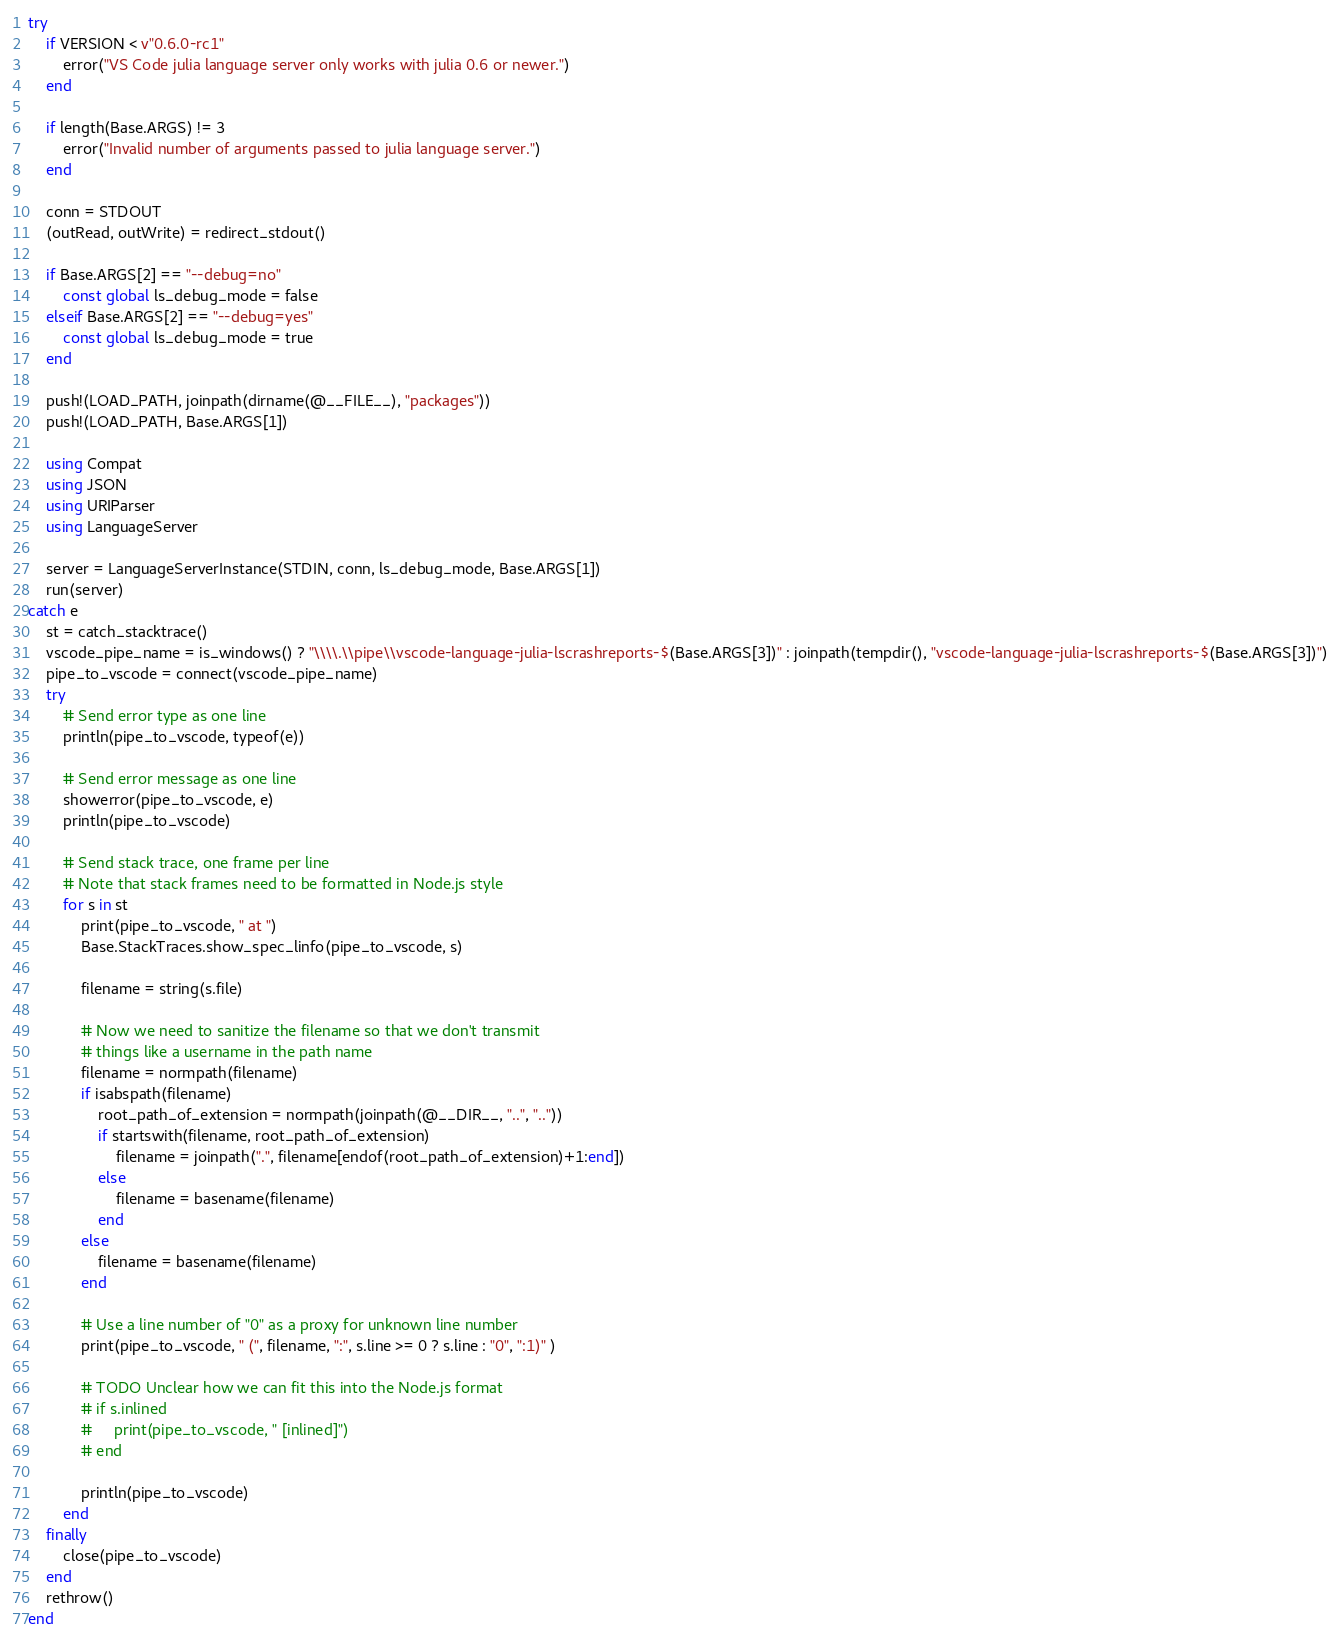Convert code to text. <code><loc_0><loc_0><loc_500><loc_500><_Julia_>try
    if VERSION < v"0.6.0-rc1"
        error("VS Code julia language server only works with julia 0.6 or newer.")
    end

    if length(Base.ARGS) != 3
        error("Invalid number of arguments passed to julia language server.")
    end

    conn = STDOUT
    (outRead, outWrite) = redirect_stdout()

    if Base.ARGS[2] == "--debug=no"
        const global ls_debug_mode = false
    elseif Base.ARGS[2] == "--debug=yes"
        const global ls_debug_mode = true
    end

    push!(LOAD_PATH, joinpath(dirname(@__FILE__), "packages"))
    push!(LOAD_PATH, Base.ARGS[1])

    using Compat
    using JSON
    using URIParser
    using LanguageServer

    server = LanguageServerInstance(STDIN, conn, ls_debug_mode, Base.ARGS[1])
    run(server)
catch e
    st = catch_stacktrace()
    vscode_pipe_name = is_windows() ? "\\\\.\\pipe\\vscode-language-julia-lscrashreports-$(Base.ARGS[3])" : joinpath(tempdir(), "vscode-language-julia-lscrashreports-$(Base.ARGS[3])")
    pipe_to_vscode = connect(vscode_pipe_name)
    try
        # Send error type as one line
        println(pipe_to_vscode, typeof(e))

        # Send error message as one line
        showerror(pipe_to_vscode, e)        
        println(pipe_to_vscode)

        # Send stack trace, one frame per line
        # Note that stack frames need to be formatted in Node.js style
        for s in st
            print(pipe_to_vscode, " at ")
            Base.StackTraces.show_spec_linfo(pipe_to_vscode, s)

            filename = string(s.file)

            # Now we need to sanitize the filename so that we don't transmit
            # things like a username in the path name
            filename = normpath(filename)
            if isabspath(filename)
                root_path_of_extension = normpath(joinpath(@__DIR__, "..", ".."))
                if startswith(filename, root_path_of_extension)
                    filename = joinpath(".", filename[endof(root_path_of_extension)+1:end])
                else
                    filename = basename(filename)
                end
            else
                filename = basename(filename)
            end

            # Use a line number of "0" as a proxy for unknown line number
            print(pipe_to_vscode, " (", filename, ":", s.line >= 0 ? s.line : "0", ":1)" )

            # TODO Unclear how we can fit this into the Node.js format
            # if s.inlined
            #     print(pipe_to_vscode, " [inlined]")
            # end

            println(pipe_to_vscode)
        end
    finally
        close(pipe_to_vscode)
    end
    rethrow()
end
</code> 